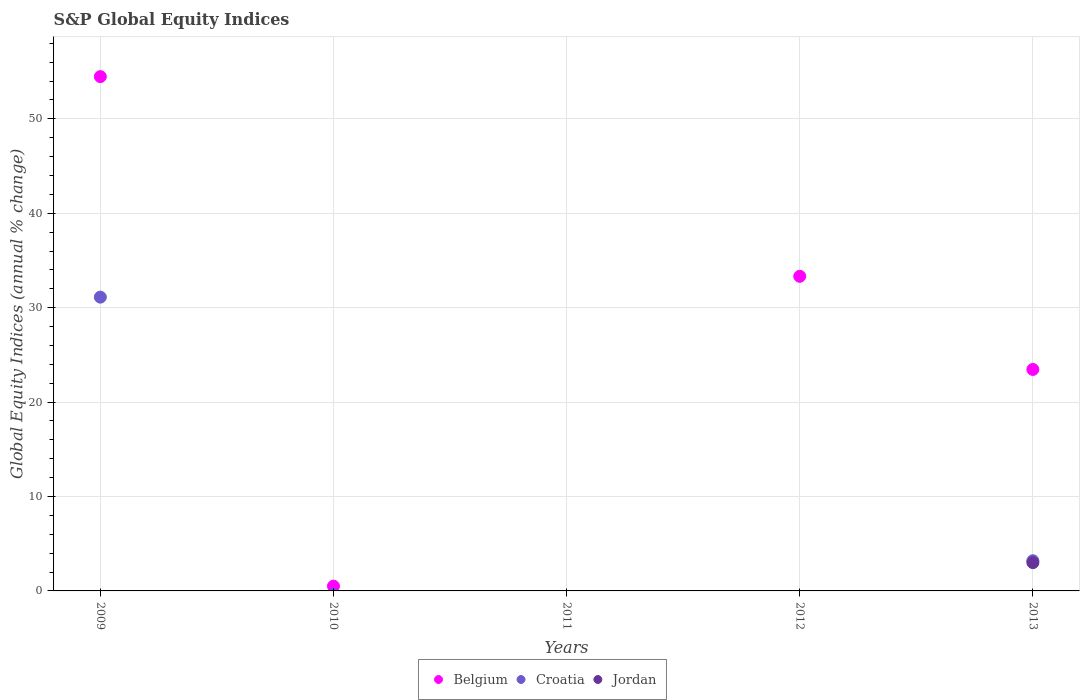Is the number of dotlines equal to the number of legend labels?
Ensure brevity in your answer.  No. Across all years, what is the maximum global equity indices in Belgium?
Your answer should be very brief. 54.47. Across all years, what is the minimum global equity indices in Jordan?
Your response must be concise. 0. In which year was the global equity indices in Jordan maximum?
Give a very brief answer. 2013. What is the total global equity indices in Croatia in the graph?
Your response must be concise. 34.31. What is the difference between the global equity indices in Croatia in 2009 and that in 2013?
Your answer should be very brief. 27.92. What is the difference between the global equity indices in Belgium in 2013 and the global equity indices in Croatia in 2012?
Ensure brevity in your answer.  23.46. What is the average global equity indices in Jordan per year?
Your response must be concise. 0.6. In the year 2013, what is the difference between the global equity indices in Jordan and global equity indices in Croatia?
Give a very brief answer. -0.2. In how many years, is the global equity indices in Belgium greater than 18 %?
Ensure brevity in your answer.  3. What is the difference between the highest and the second highest global equity indices in Belgium?
Your answer should be very brief. 21.15. What is the difference between the highest and the lowest global equity indices in Belgium?
Your answer should be very brief. 54.47. In how many years, is the global equity indices in Belgium greater than the average global equity indices in Belgium taken over all years?
Make the answer very short. 3. Is the sum of the global equity indices in Croatia in 2009 and 2013 greater than the maximum global equity indices in Belgium across all years?
Give a very brief answer. No. Is it the case that in every year, the sum of the global equity indices in Croatia and global equity indices in Belgium  is greater than the global equity indices in Jordan?
Your answer should be very brief. No. Does the global equity indices in Jordan monotonically increase over the years?
Give a very brief answer. No. Is the global equity indices in Belgium strictly greater than the global equity indices in Croatia over the years?
Provide a short and direct response. Yes. What is the difference between two consecutive major ticks on the Y-axis?
Offer a terse response. 10. Does the graph contain any zero values?
Offer a very short reply. Yes. Where does the legend appear in the graph?
Offer a terse response. Bottom center. How many legend labels are there?
Your response must be concise. 3. What is the title of the graph?
Your response must be concise. S&P Global Equity Indices. What is the label or title of the X-axis?
Your response must be concise. Years. What is the label or title of the Y-axis?
Provide a short and direct response. Global Equity Indices (annual % change). What is the Global Equity Indices (annual % change) in Belgium in 2009?
Keep it short and to the point. 54.47. What is the Global Equity Indices (annual % change) in Croatia in 2009?
Ensure brevity in your answer.  31.11. What is the Global Equity Indices (annual % change) of Jordan in 2009?
Ensure brevity in your answer.  0. What is the Global Equity Indices (annual % change) in Belgium in 2010?
Your answer should be compact. 0.5. What is the Global Equity Indices (annual % change) in Jordan in 2010?
Give a very brief answer. 0. What is the Global Equity Indices (annual % change) in Belgium in 2012?
Keep it short and to the point. 33.32. What is the Global Equity Indices (annual % change) in Jordan in 2012?
Keep it short and to the point. 0. What is the Global Equity Indices (annual % change) in Belgium in 2013?
Provide a succinct answer. 23.46. What is the Global Equity Indices (annual % change) in Croatia in 2013?
Provide a succinct answer. 3.2. What is the Global Equity Indices (annual % change) in Jordan in 2013?
Ensure brevity in your answer.  3. Across all years, what is the maximum Global Equity Indices (annual % change) of Belgium?
Provide a succinct answer. 54.47. Across all years, what is the maximum Global Equity Indices (annual % change) of Croatia?
Provide a succinct answer. 31.11. Across all years, what is the maximum Global Equity Indices (annual % change) in Jordan?
Make the answer very short. 3. Across all years, what is the minimum Global Equity Indices (annual % change) in Belgium?
Make the answer very short. 0. What is the total Global Equity Indices (annual % change) in Belgium in the graph?
Make the answer very short. 111.75. What is the total Global Equity Indices (annual % change) in Croatia in the graph?
Give a very brief answer. 34.31. What is the total Global Equity Indices (annual % change) of Jordan in the graph?
Make the answer very short. 3. What is the difference between the Global Equity Indices (annual % change) in Belgium in 2009 and that in 2010?
Offer a terse response. 53.97. What is the difference between the Global Equity Indices (annual % change) in Belgium in 2009 and that in 2012?
Ensure brevity in your answer.  21.15. What is the difference between the Global Equity Indices (annual % change) in Belgium in 2009 and that in 2013?
Give a very brief answer. 31.01. What is the difference between the Global Equity Indices (annual % change) in Croatia in 2009 and that in 2013?
Provide a short and direct response. 27.92. What is the difference between the Global Equity Indices (annual % change) of Belgium in 2010 and that in 2012?
Your answer should be very brief. -32.82. What is the difference between the Global Equity Indices (annual % change) of Belgium in 2010 and that in 2013?
Your answer should be very brief. -22.95. What is the difference between the Global Equity Indices (annual % change) in Belgium in 2012 and that in 2013?
Keep it short and to the point. 9.86. What is the difference between the Global Equity Indices (annual % change) of Belgium in 2009 and the Global Equity Indices (annual % change) of Croatia in 2013?
Keep it short and to the point. 51.27. What is the difference between the Global Equity Indices (annual % change) in Belgium in 2009 and the Global Equity Indices (annual % change) in Jordan in 2013?
Give a very brief answer. 51.47. What is the difference between the Global Equity Indices (annual % change) of Croatia in 2009 and the Global Equity Indices (annual % change) of Jordan in 2013?
Your answer should be compact. 28.12. What is the difference between the Global Equity Indices (annual % change) in Belgium in 2010 and the Global Equity Indices (annual % change) in Croatia in 2013?
Your answer should be very brief. -2.69. What is the difference between the Global Equity Indices (annual % change) in Belgium in 2010 and the Global Equity Indices (annual % change) in Jordan in 2013?
Make the answer very short. -2.49. What is the difference between the Global Equity Indices (annual % change) in Belgium in 2012 and the Global Equity Indices (annual % change) in Croatia in 2013?
Provide a short and direct response. 30.12. What is the difference between the Global Equity Indices (annual % change) in Belgium in 2012 and the Global Equity Indices (annual % change) in Jordan in 2013?
Give a very brief answer. 30.32. What is the average Global Equity Indices (annual % change) in Belgium per year?
Provide a succinct answer. 22.35. What is the average Global Equity Indices (annual % change) of Croatia per year?
Provide a succinct answer. 6.86. What is the average Global Equity Indices (annual % change) of Jordan per year?
Give a very brief answer. 0.6. In the year 2009, what is the difference between the Global Equity Indices (annual % change) of Belgium and Global Equity Indices (annual % change) of Croatia?
Give a very brief answer. 23.35. In the year 2013, what is the difference between the Global Equity Indices (annual % change) of Belgium and Global Equity Indices (annual % change) of Croatia?
Your answer should be compact. 20.26. In the year 2013, what is the difference between the Global Equity Indices (annual % change) in Belgium and Global Equity Indices (annual % change) in Jordan?
Your response must be concise. 20.46. In the year 2013, what is the difference between the Global Equity Indices (annual % change) in Croatia and Global Equity Indices (annual % change) in Jordan?
Your response must be concise. 0.2. What is the ratio of the Global Equity Indices (annual % change) in Belgium in 2009 to that in 2010?
Keep it short and to the point. 108.34. What is the ratio of the Global Equity Indices (annual % change) in Belgium in 2009 to that in 2012?
Your response must be concise. 1.63. What is the ratio of the Global Equity Indices (annual % change) in Belgium in 2009 to that in 2013?
Your response must be concise. 2.32. What is the ratio of the Global Equity Indices (annual % change) of Croatia in 2009 to that in 2013?
Provide a short and direct response. 9.73. What is the ratio of the Global Equity Indices (annual % change) of Belgium in 2010 to that in 2012?
Ensure brevity in your answer.  0.02. What is the ratio of the Global Equity Indices (annual % change) of Belgium in 2010 to that in 2013?
Make the answer very short. 0.02. What is the ratio of the Global Equity Indices (annual % change) in Belgium in 2012 to that in 2013?
Offer a very short reply. 1.42. What is the difference between the highest and the second highest Global Equity Indices (annual % change) of Belgium?
Make the answer very short. 21.15. What is the difference between the highest and the lowest Global Equity Indices (annual % change) in Belgium?
Offer a terse response. 54.47. What is the difference between the highest and the lowest Global Equity Indices (annual % change) in Croatia?
Your response must be concise. 31.11. What is the difference between the highest and the lowest Global Equity Indices (annual % change) of Jordan?
Provide a succinct answer. 3. 